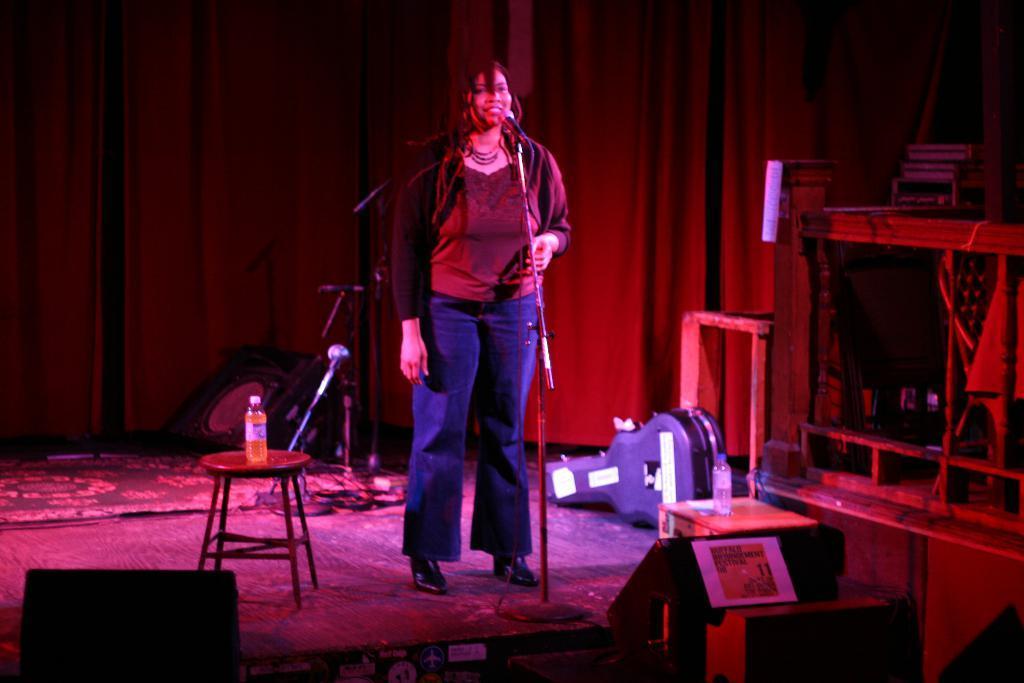Can you describe this image briefly? In this image I can see a person standing in front of the microphone, background I can see a bottle on the table and I can also see few objects and I can see colorful lights. 